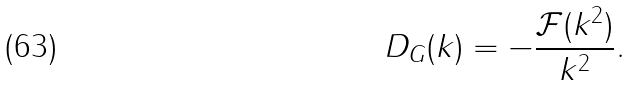<formula> <loc_0><loc_0><loc_500><loc_500>D _ { G } ( k ) = - \frac { \mathcal { F } ( k ^ { 2 } ) } { k ^ { 2 } } .</formula> 